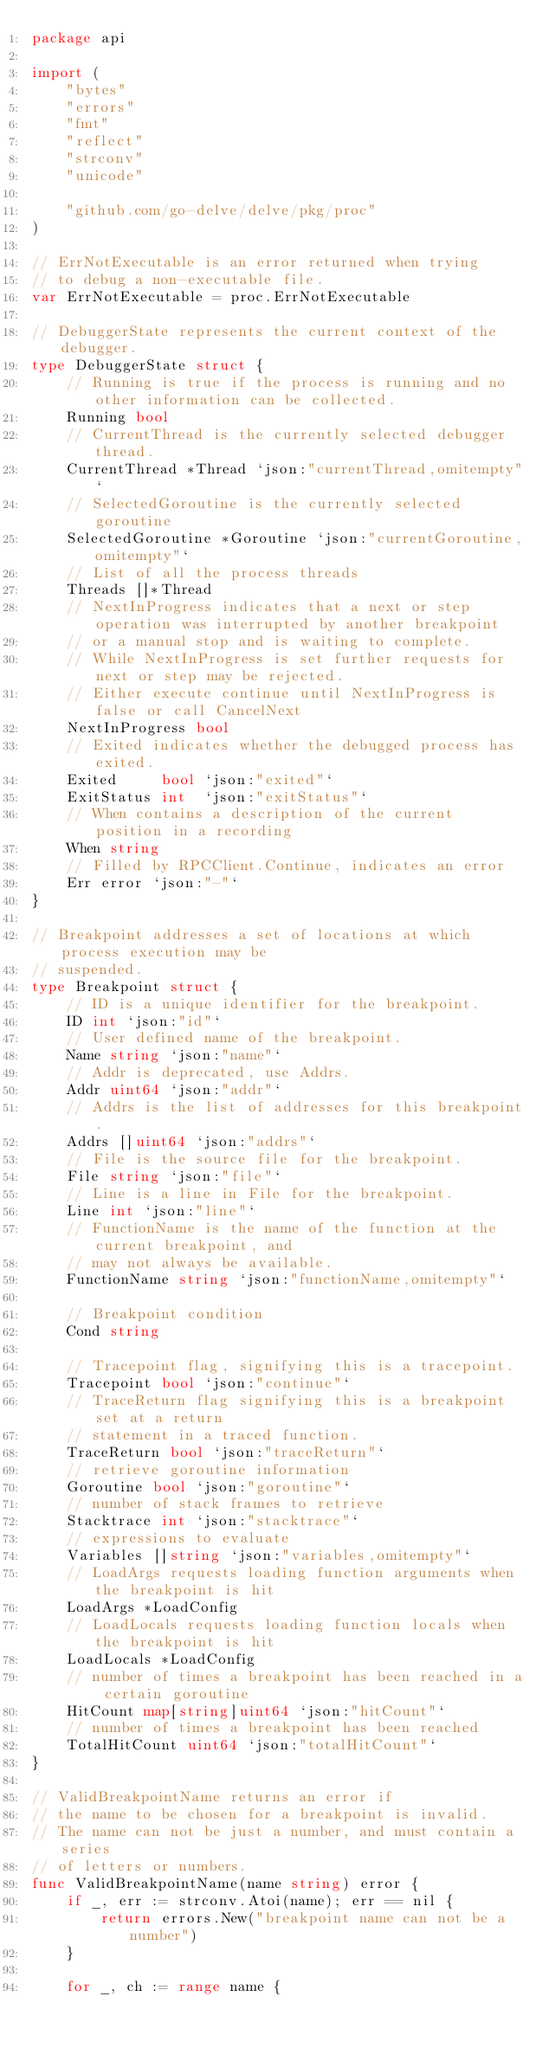<code> <loc_0><loc_0><loc_500><loc_500><_Go_>package api

import (
	"bytes"
	"errors"
	"fmt"
	"reflect"
	"strconv"
	"unicode"

	"github.com/go-delve/delve/pkg/proc"
)

// ErrNotExecutable is an error returned when trying
// to debug a non-executable file.
var ErrNotExecutable = proc.ErrNotExecutable

// DebuggerState represents the current context of the debugger.
type DebuggerState struct {
	// Running is true if the process is running and no other information can be collected.
	Running bool
	// CurrentThread is the currently selected debugger thread.
	CurrentThread *Thread `json:"currentThread,omitempty"`
	// SelectedGoroutine is the currently selected goroutine
	SelectedGoroutine *Goroutine `json:"currentGoroutine,omitempty"`
	// List of all the process threads
	Threads []*Thread
	// NextInProgress indicates that a next or step operation was interrupted by another breakpoint
	// or a manual stop and is waiting to complete.
	// While NextInProgress is set further requests for next or step may be rejected.
	// Either execute continue until NextInProgress is false or call CancelNext
	NextInProgress bool
	// Exited indicates whether the debugged process has exited.
	Exited     bool `json:"exited"`
	ExitStatus int  `json:"exitStatus"`
	// When contains a description of the current position in a recording
	When string
	// Filled by RPCClient.Continue, indicates an error
	Err error `json:"-"`
}

// Breakpoint addresses a set of locations at which process execution may be
// suspended.
type Breakpoint struct {
	// ID is a unique identifier for the breakpoint.
	ID int `json:"id"`
	// User defined name of the breakpoint.
	Name string `json:"name"`
	// Addr is deprecated, use Addrs.
	Addr uint64 `json:"addr"`
	// Addrs is the list of addresses for this breakpoint.
	Addrs []uint64 `json:"addrs"`
	// File is the source file for the breakpoint.
	File string `json:"file"`
	// Line is a line in File for the breakpoint.
	Line int `json:"line"`
	// FunctionName is the name of the function at the current breakpoint, and
	// may not always be available.
	FunctionName string `json:"functionName,omitempty"`

	// Breakpoint condition
	Cond string

	// Tracepoint flag, signifying this is a tracepoint.
	Tracepoint bool `json:"continue"`
	// TraceReturn flag signifying this is a breakpoint set at a return
	// statement in a traced function.
	TraceReturn bool `json:"traceReturn"`
	// retrieve goroutine information
	Goroutine bool `json:"goroutine"`
	// number of stack frames to retrieve
	Stacktrace int `json:"stacktrace"`
	// expressions to evaluate
	Variables []string `json:"variables,omitempty"`
	// LoadArgs requests loading function arguments when the breakpoint is hit
	LoadArgs *LoadConfig
	// LoadLocals requests loading function locals when the breakpoint is hit
	LoadLocals *LoadConfig
	// number of times a breakpoint has been reached in a certain goroutine
	HitCount map[string]uint64 `json:"hitCount"`
	// number of times a breakpoint has been reached
	TotalHitCount uint64 `json:"totalHitCount"`
}

// ValidBreakpointName returns an error if
// the name to be chosen for a breakpoint is invalid.
// The name can not be just a number, and must contain a series
// of letters or numbers.
func ValidBreakpointName(name string) error {
	if _, err := strconv.Atoi(name); err == nil {
		return errors.New("breakpoint name can not be a number")
	}

	for _, ch := range name {</code> 